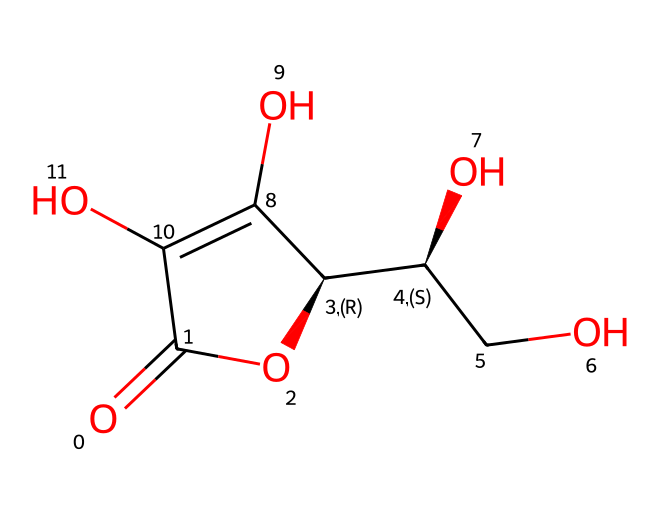What is the molecular formula of ascorbic acid? The SMILES representation indicates the presence of carbon (C), hydrogen (H), and oxygen (O) atoms. By counting the various elements represented in the structure, the molecular formula can be identified as C6H8O6.
Answer: C6H8O6 How many oxygen atoms are in the molecular structure? By analyzing the SMILES, we can count the number of 'O' present. There are a total of 6 oxygen atoms within the structure.
Answer: 6 What functional groups are present in ascorbic acid? The structure contains hydroxyl groups (-OH) and a lactone ring, which indicates the presence of these functional groups specifically in ascorbic acid.
Answer: hydroxyl and lactone Is ascorbic acid a reducing agent? Ascorbic acid is known for its antioxidant properties, which include reducing agents due to its ability to donate electrons.
Answer: Yes What is the chiral center count in ascorbic acid? The structure shows carbon atoms attached to four different substituents at certain positions, indicating the presence of chiral centers. In this case, there are 2 chiral centers in the molecule.
Answer: 2 How does ascorbic acid contribute to antioxidant activity? The presence of hydroxyl groups in ascorbic acid structure allows it to effectively donate electrons, which contributes to its ability to neutralize free radicals.
Answer: Electron donation What is the relevance of ascorbic acid concentration in Swiss alpine berries? Swiss alpine berries are known for their high concentration of ascorbic acid, which enhances their nutritional value and antioxidant capacity. This characteristic is particularly significant for health benefits.
Answer: High concentration 